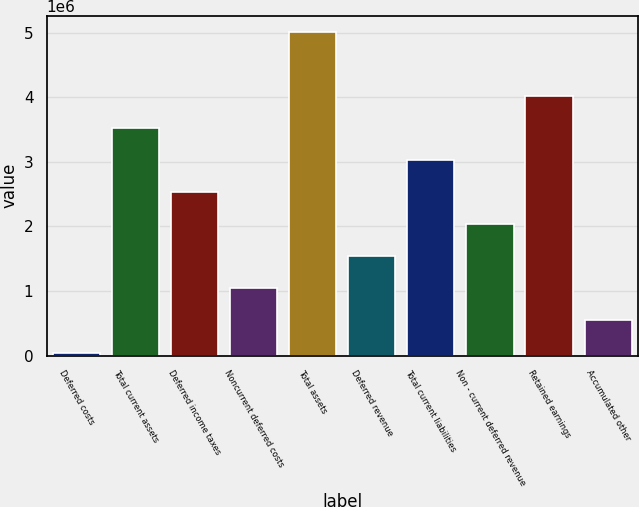Convert chart. <chart><loc_0><loc_0><loc_500><loc_500><bar_chart><fcel>Deferred costs<fcel>Total current assets<fcel>Deferred income taxes<fcel>Noncurrent deferred costs<fcel>Total assets<fcel>Deferred revenue<fcel>Total current liabilities<fcel>Non - current deferred revenue<fcel>Retained earnings<fcel>Accumulated other<nl><fcel>48312<fcel>3.52168e+06<fcel>2.52929e+06<fcel>1.0407e+06<fcel>5.01026e+06<fcel>1.5369e+06<fcel>3.02548e+06<fcel>2.03309e+06<fcel>4.01787e+06<fcel>544507<nl></chart> 